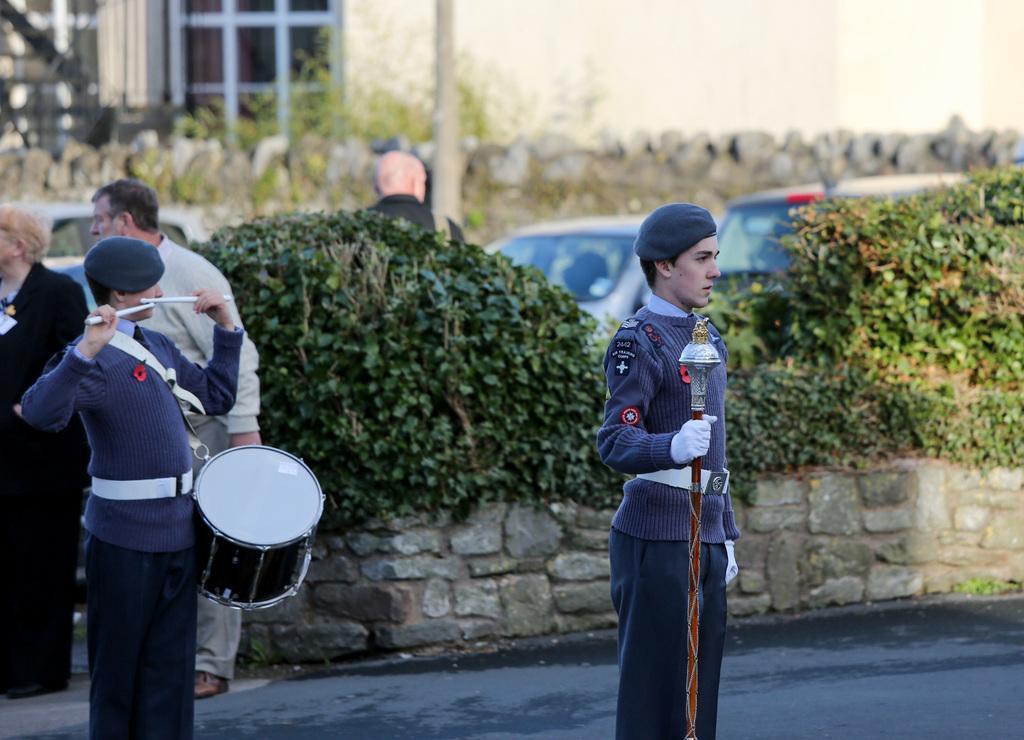Can you describe this image briefly? In the image there are two soldiers standing on the road, one is playing drum and another is holding stick and behind there are plants on the wall with three people walking on the road followed by cars behind it and over the background there are buildings with wall in front of it. 